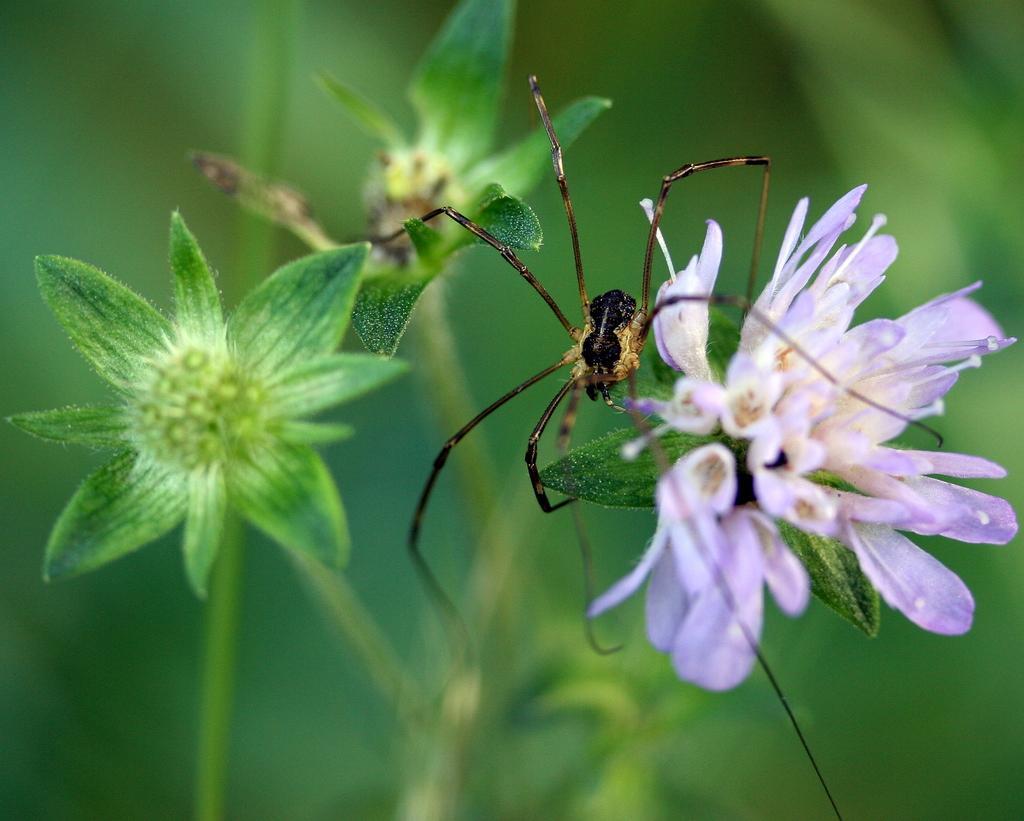How would you summarize this image in a sentence or two? In the image we can see an insect and flowers, and the background is blurred. 